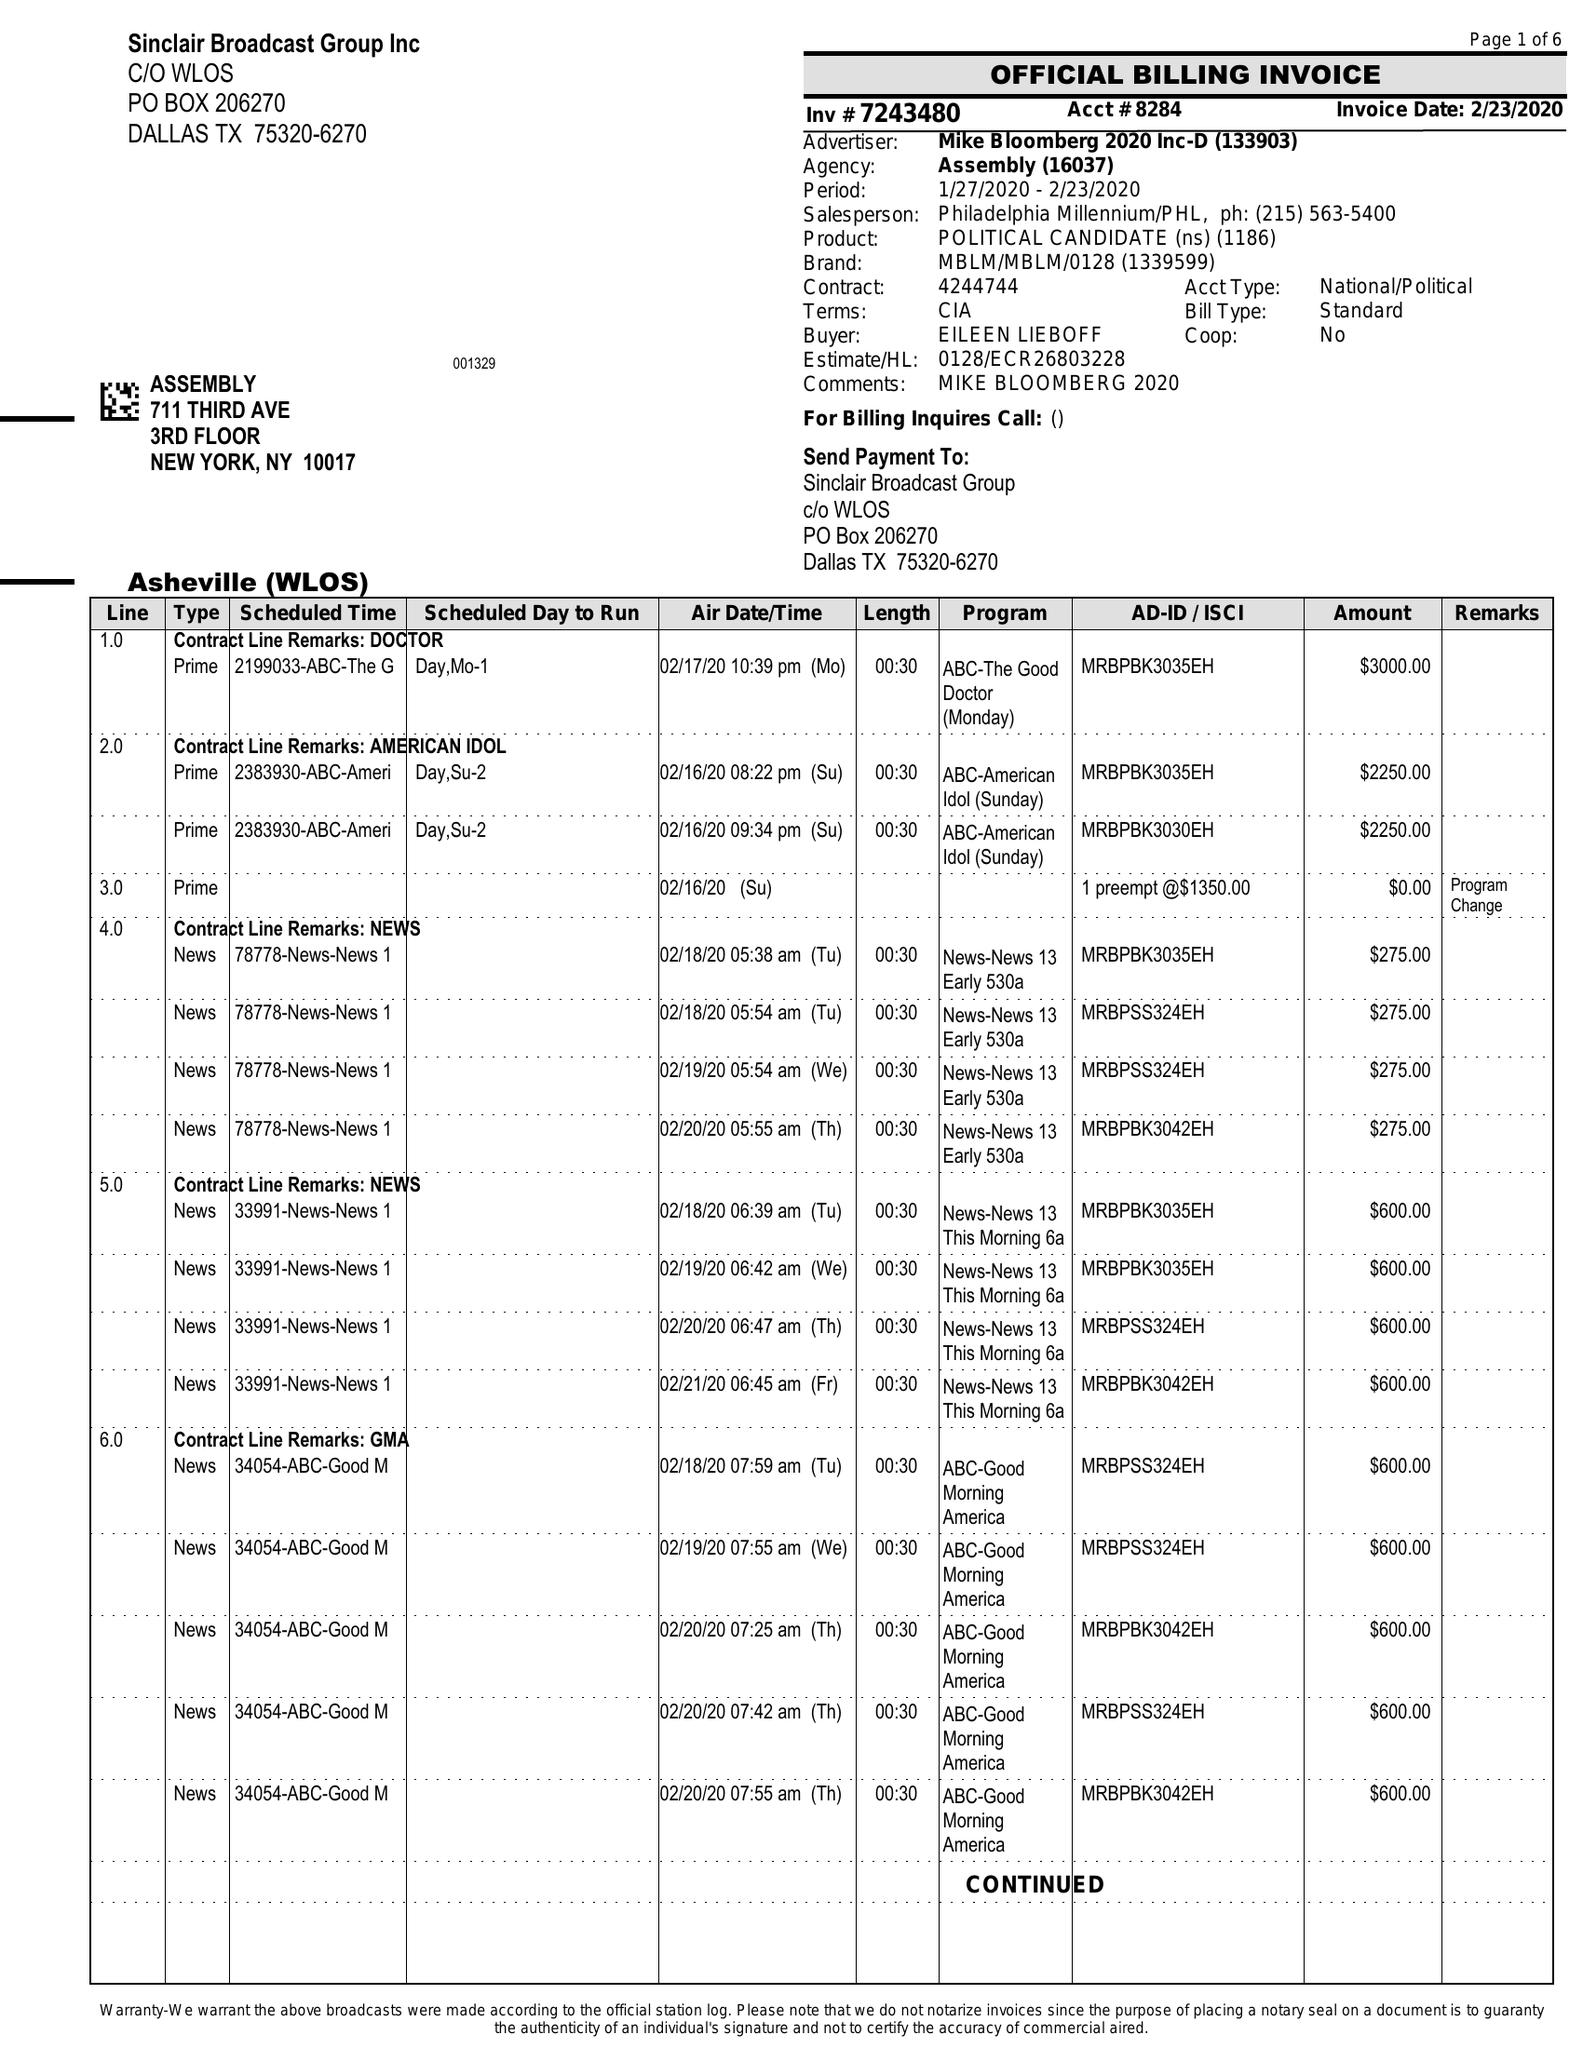What is the value for the flight_to?
Answer the question using a single word or phrase. 02/23/20 